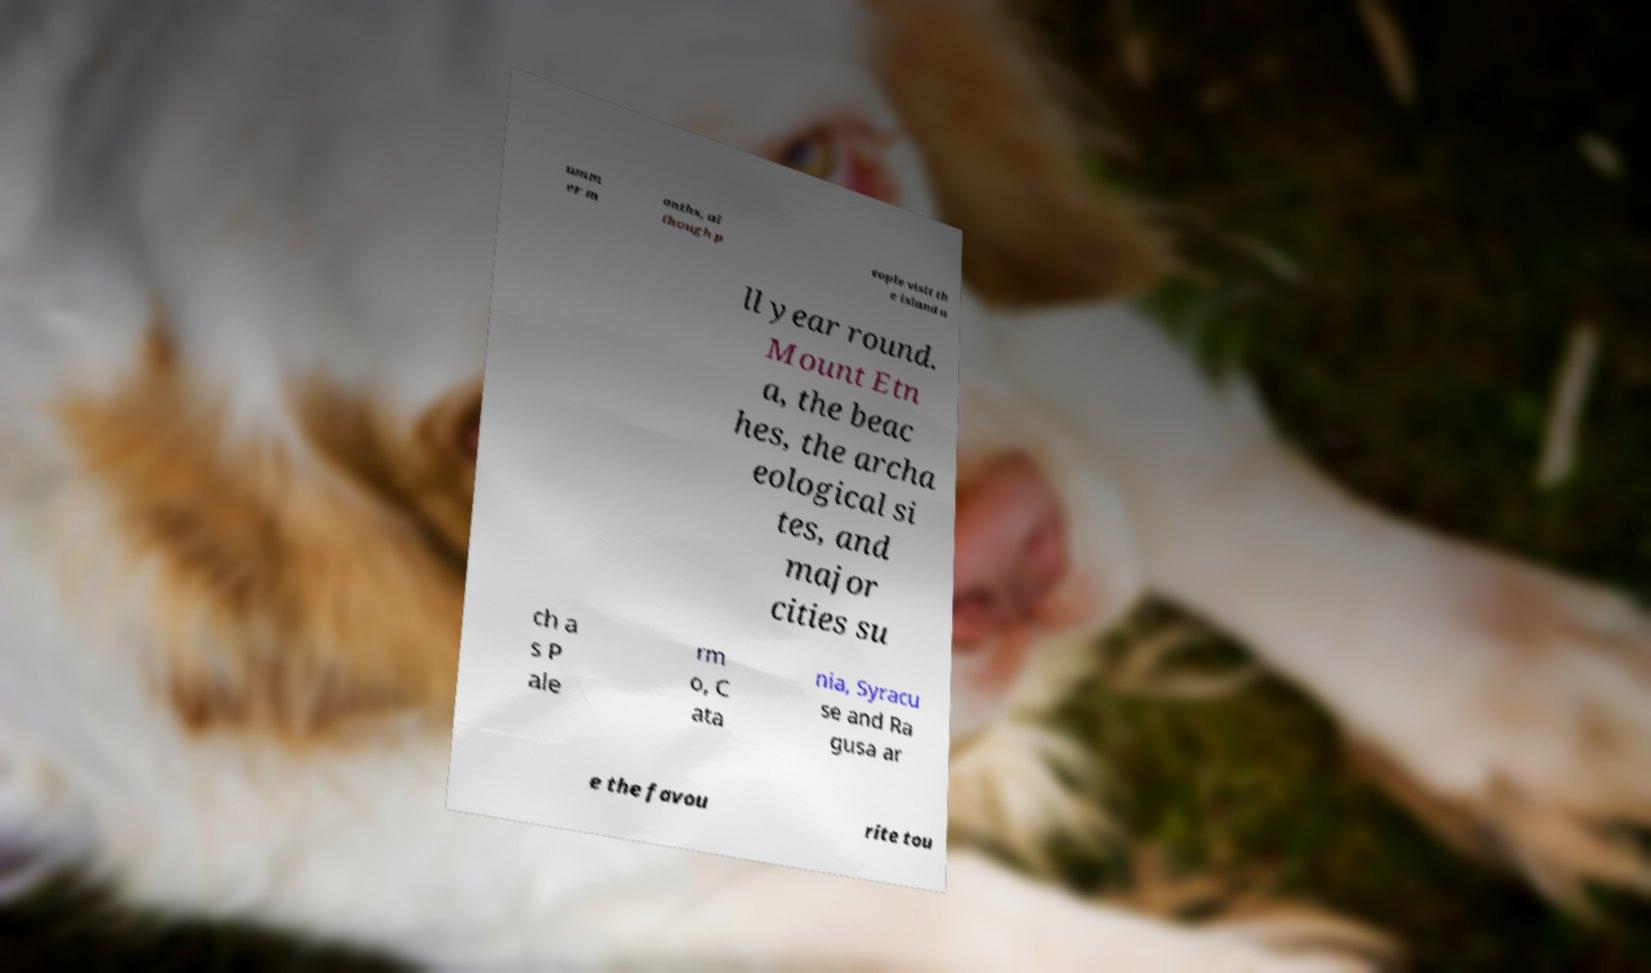There's text embedded in this image that I need extracted. Can you transcribe it verbatim? umm er m onths, al though p eople visit th e island a ll year round. Mount Etn a, the beac hes, the archa eological si tes, and major cities su ch a s P ale rm o, C ata nia, Syracu se and Ra gusa ar e the favou rite tou 